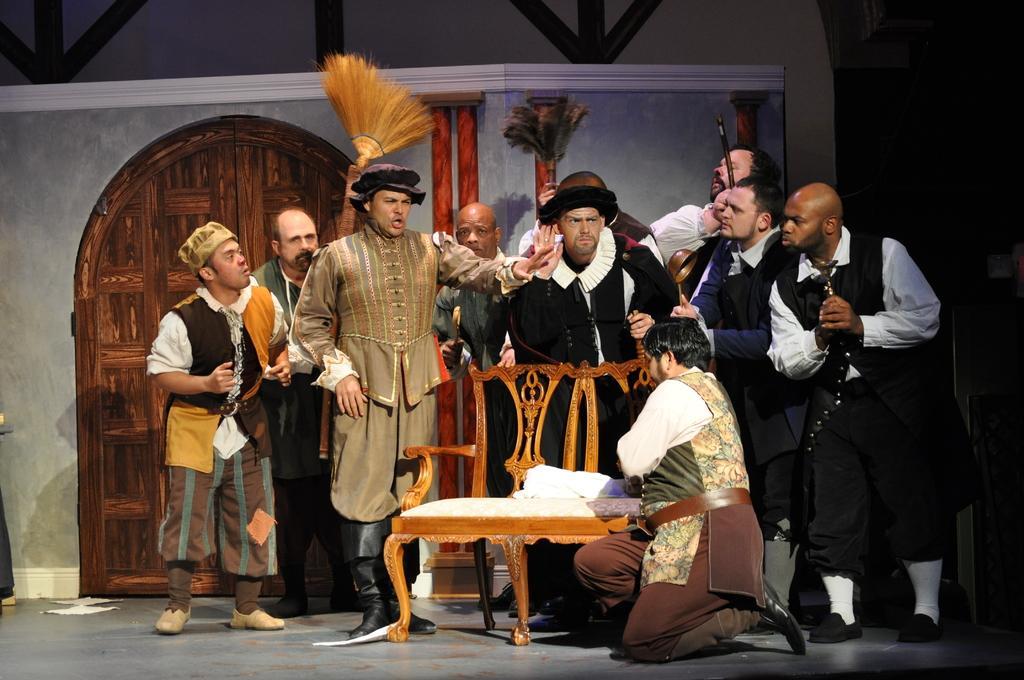In one or two sentences, can you explain what this image depicts? In this image we can see a group of people are standing and one person is talking, maybe they are playing an act. In the background of the image we can see a door. 